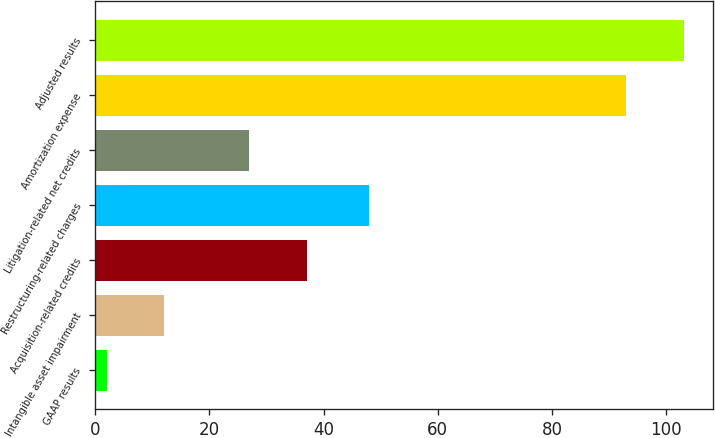<chart> <loc_0><loc_0><loc_500><loc_500><bar_chart><fcel>GAAP results<fcel>Intangible asset impairment<fcel>Acquisition-related credits<fcel>Restructuring-related charges<fcel>Litigation-related net credits<fcel>Amortization expense<fcel>Adjusted results<nl><fcel>2<fcel>12.1<fcel>37.1<fcel>48<fcel>27<fcel>93<fcel>103.1<nl></chart> 